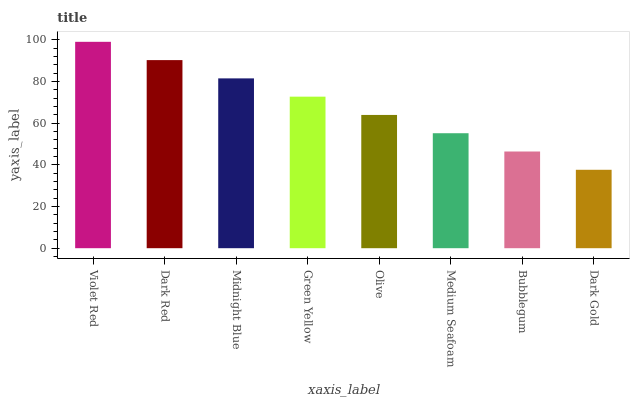Is Dark Gold the minimum?
Answer yes or no. Yes. Is Violet Red the maximum?
Answer yes or no. Yes. Is Dark Red the minimum?
Answer yes or no. No. Is Dark Red the maximum?
Answer yes or no. No. Is Violet Red greater than Dark Red?
Answer yes or no. Yes. Is Dark Red less than Violet Red?
Answer yes or no. Yes. Is Dark Red greater than Violet Red?
Answer yes or no. No. Is Violet Red less than Dark Red?
Answer yes or no. No. Is Green Yellow the high median?
Answer yes or no. Yes. Is Olive the low median?
Answer yes or no. Yes. Is Bubblegum the high median?
Answer yes or no. No. Is Dark Red the low median?
Answer yes or no. No. 